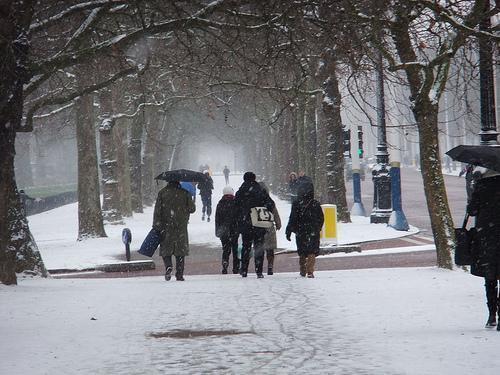How many umbrellas are there?
Give a very brief answer. 2. How many people have umbrellas?
Give a very brief answer. 2. 